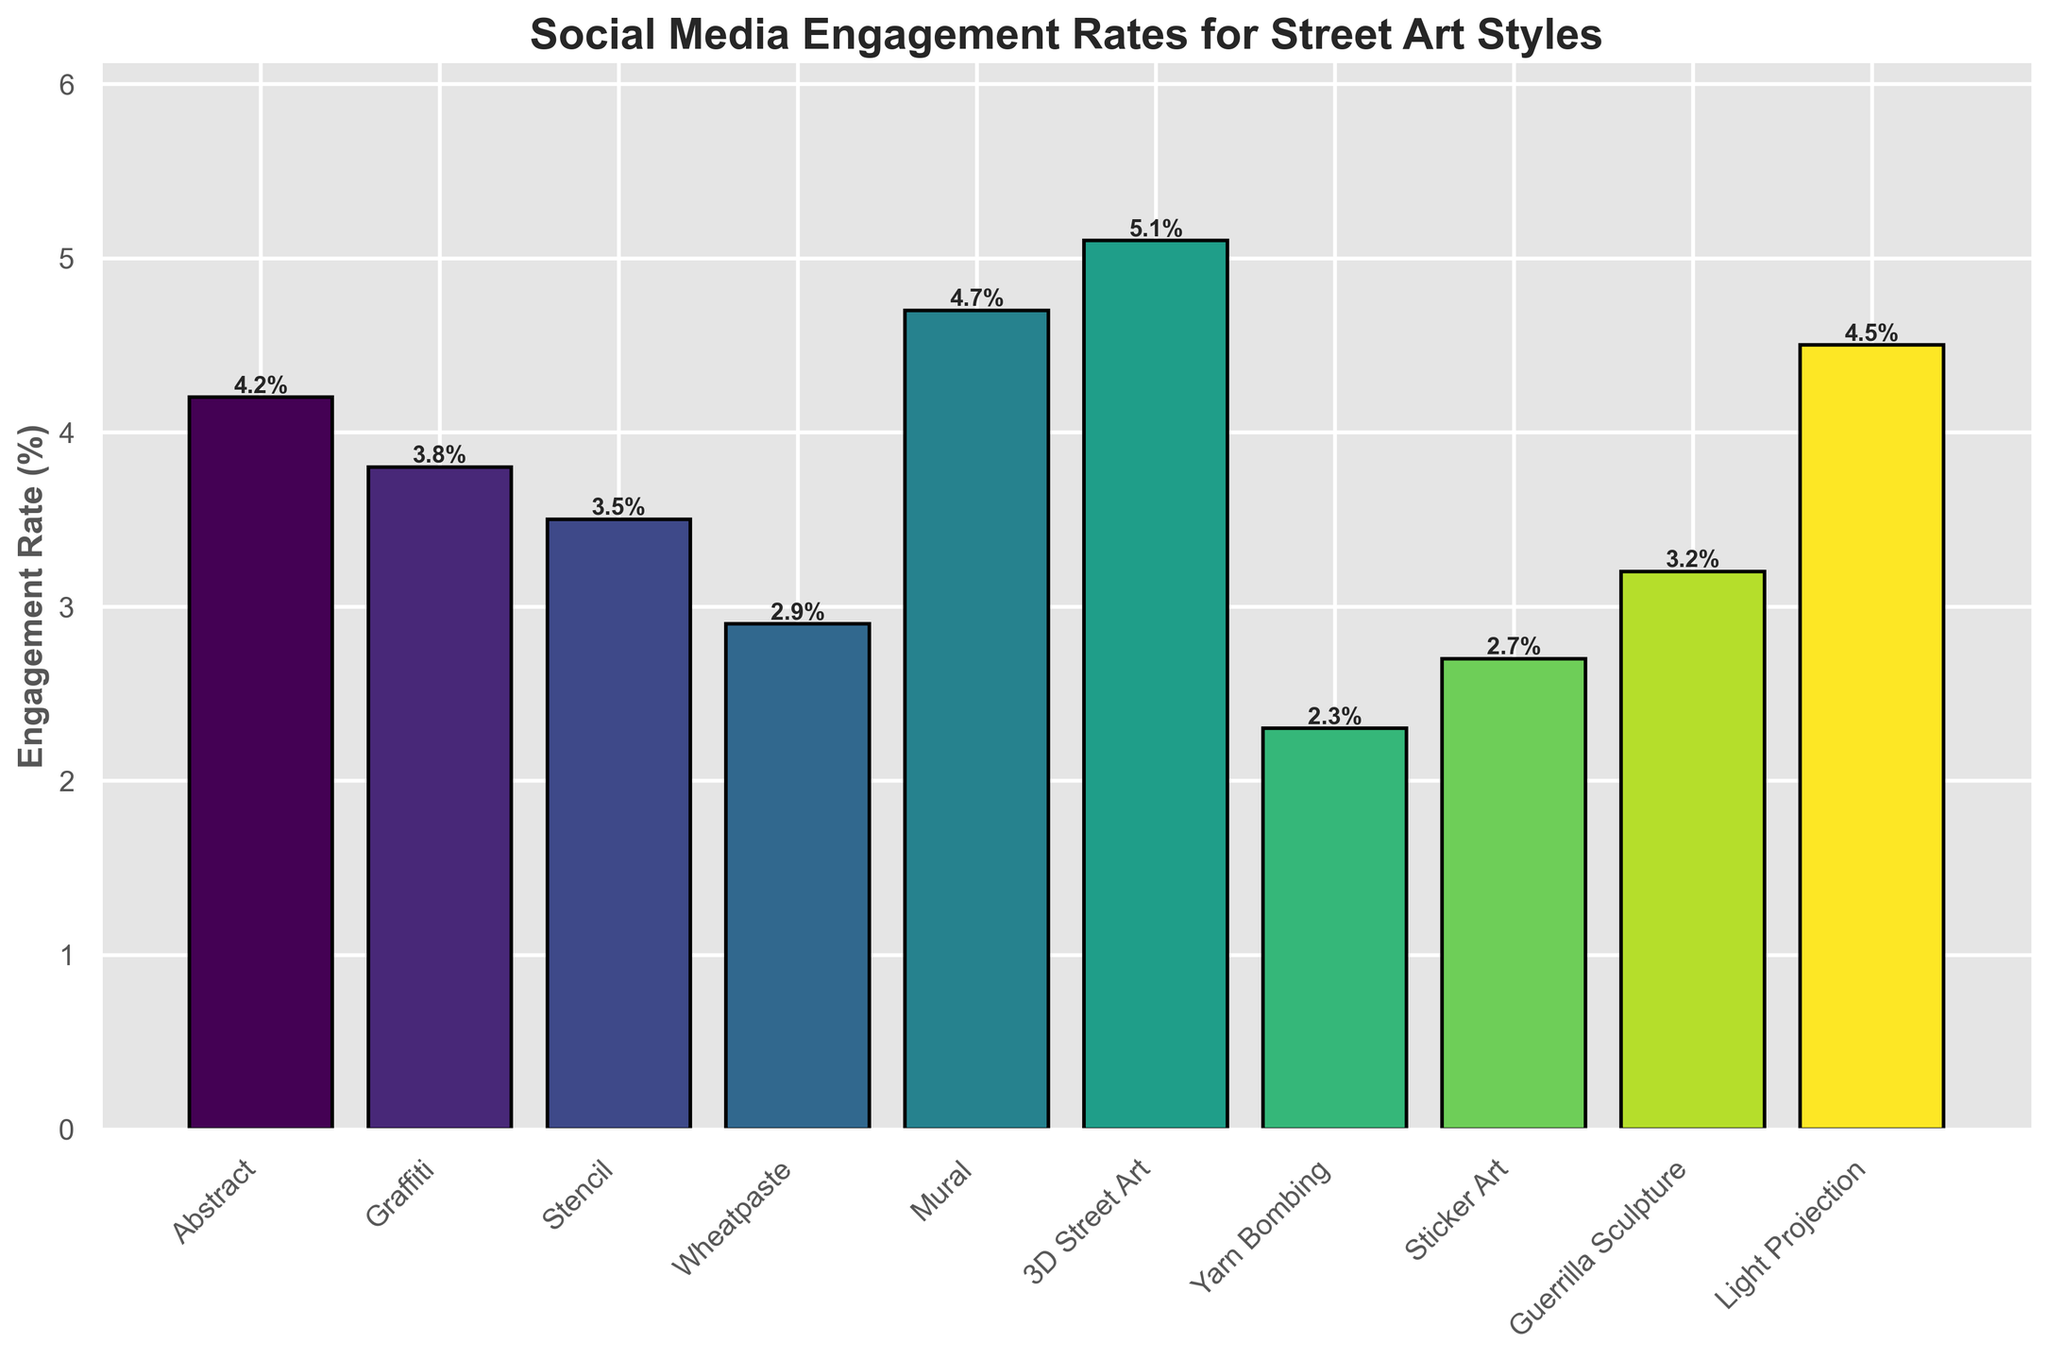Which street art style has the highest engagement rate? The height of the bars shows engagement rates for each style. By comparing the heights, we see that 3D Street Art has the tallest bar.
Answer: 3D Street Art Which style has a higher engagement rate, Abstract or Sticker Art? Compare the heights of the bars for Abstract and Sticker Art. The bar for Abstract is higher.
Answer: Abstract What's the average engagement rate of Murals, Stencil, and Light Projection? Sum the engagement rates of Murals (4.7), Stencil (3.5), and Light Projection (4.5) and divide by 3. (4.7 + 3.5 + 4.5) / 3 = 4.23
Answer: 4.23 Is there any style with an engagement rate less than 3%? If yes, name them. Check the bars with heights below 3%. Yarn Bombing (2.3), Wheatpaste (2.9), and Sticker Art (2.7) are below 3%.
Answer: Yarn Bombing, Wheatpaste, Sticker Art What is the difference in engagement rates between the style with the highest rate and the style with the lowest rate? Find the highest (3D Street Art, 5.1%) and the lowest (Yarn Bombing, 2.3%) rates, then subtract: 5.1 - 2.3 = 2.8
Answer: 2.8 Which style has an engagement rate closest to 3%? Compare the engagement rates that are near 3% and find the closest value. Guerrilla Sculpture has a rate of 3.2%, closest to 3%.
Answer: Guerrilla Sculpture Are there more styles with engagement rates above 4% or below 3%? Count the bars above 4%: Abstract (4.2), Mural (4.7), 3D Street Art (5.1), Light Projection (4.5), and those below 3%: Yarn Bombing (2.3), Sticker Art (2.7), Wheatpaste (2.9). There are 4 styles above 4% and 3 below 3%.
Answer: Above 4% What is the combined engagement rate for Graffiti and Yarn Bombing? Add the engagement rates for Graffiti (3.8) and Yarn Bombing (2.3). 3.8 + 2.3 = 6.1
Answer: 6.1 Compare the engagement rate of Mural and Light Projection. Which is higher and by how much? Mural has an engagement rate of 4.7%, and Light Projection has 4.5%. The difference is 4.7 - 4.5 = 0.2. Mural is higher.
Answer: Mural by 0.2 